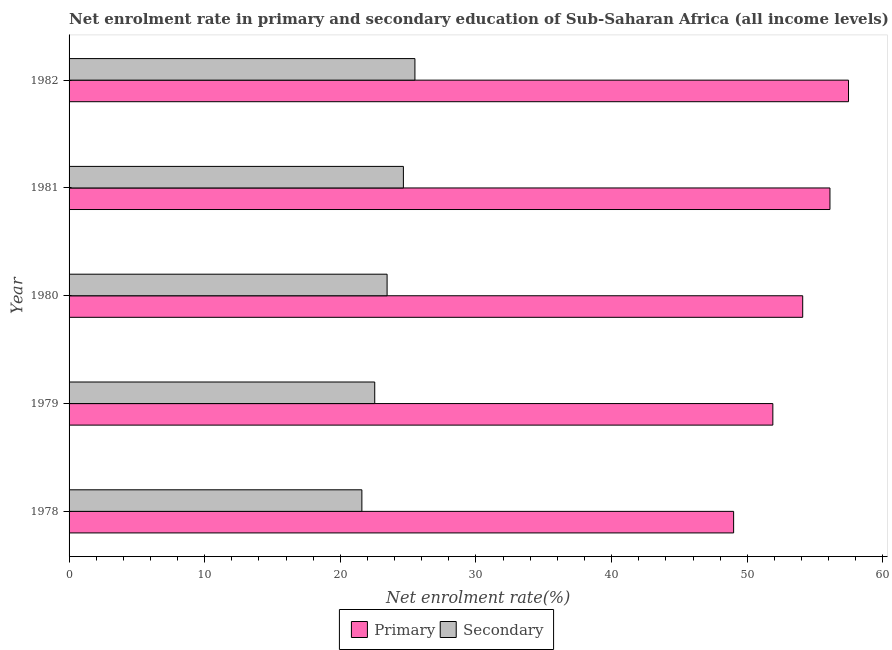How many groups of bars are there?
Your answer should be very brief. 5. How many bars are there on the 5th tick from the bottom?
Provide a succinct answer. 2. What is the label of the 2nd group of bars from the top?
Your response must be concise. 1981. What is the enrollment rate in primary education in 1980?
Your response must be concise. 54.09. Across all years, what is the maximum enrollment rate in secondary education?
Your answer should be very brief. 25.5. Across all years, what is the minimum enrollment rate in secondary education?
Provide a succinct answer. 21.59. In which year was the enrollment rate in secondary education maximum?
Ensure brevity in your answer.  1982. In which year was the enrollment rate in secondary education minimum?
Give a very brief answer. 1978. What is the total enrollment rate in primary education in the graph?
Offer a very short reply. 268.53. What is the difference between the enrollment rate in primary education in 1978 and that in 1981?
Your answer should be compact. -7.1. What is the difference between the enrollment rate in primary education in 1982 and the enrollment rate in secondary education in 1980?
Provide a succinct answer. 34.02. What is the average enrollment rate in primary education per year?
Offer a very short reply. 53.71. In the year 1982, what is the difference between the enrollment rate in secondary education and enrollment rate in primary education?
Your answer should be compact. -31.97. In how many years, is the enrollment rate in secondary education greater than 18 %?
Ensure brevity in your answer.  5. What is the ratio of the enrollment rate in primary education in 1980 to that in 1982?
Keep it short and to the point. 0.94. Is the difference between the enrollment rate in secondary education in 1980 and 1981 greater than the difference between the enrollment rate in primary education in 1980 and 1981?
Keep it short and to the point. Yes. What is the difference between the highest and the second highest enrollment rate in primary education?
Offer a very short reply. 1.37. What is the difference between the highest and the lowest enrollment rate in primary education?
Provide a short and direct response. 8.47. In how many years, is the enrollment rate in secondary education greater than the average enrollment rate in secondary education taken over all years?
Provide a succinct answer. 2. Is the sum of the enrollment rate in secondary education in 1978 and 1980 greater than the maximum enrollment rate in primary education across all years?
Ensure brevity in your answer.  No. What does the 2nd bar from the top in 1982 represents?
Ensure brevity in your answer.  Primary. What does the 1st bar from the bottom in 1980 represents?
Your answer should be compact. Primary. Does the graph contain any zero values?
Your answer should be very brief. No. Does the graph contain grids?
Provide a short and direct response. No. How are the legend labels stacked?
Provide a short and direct response. Horizontal. What is the title of the graph?
Your answer should be very brief. Net enrolment rate in primary and secondary education of Sub-Saharan Africa (all income levels). Does "Old" appear as one of the legend labels in the graph?
Keep it short and to the point. No. What is the label or title of the X-axis?
Your response must be concise. Net enrolment rate(%). What is the label or title of the Y-axis?
Provide a succinct answer. Year. What is the Net enrolment rate(%) of Primary in 1978?
Provide a succinct answer. 48.99. What is the Net enrolment rate(%) in Secondary in 1978?
Your response must be concise. 21.59. What is the Net enrolment rate(%) in Primary in 1979?
Provide a succinct answer. 51.89. What is the Net enrolment rate(%) of Secondary in 1979?
Make the answer very short. 22.54. What is the Net enrolment rate(%) in Primary in 1980?
Your response must be concise. 54.09. What is the Net enrolment rate(%) of Secondary in 1980?
Give a very brief answer. 23.45. What is the Net enrolment rate(%) in Primary in 1981?
Your answer should be compact. 56.1. What is the Net enrolment rate(%) of Secondary in 1981?
Provide a succinct answer. 24.65. What is the Net enrolment rate(%) in Primary in 1982?
Keep it short and to the point. 57.47. What is the Net enrolment rate(%) in Secondary in 1982?
Offer a terse response. 25.5. Across all years, what is the maximum Net enrolment rate(%) in Primary?
Offer a very short reply. 57.47. Across all years, what is the maximum Net enrolment rate(%) of Secondary?
Give a very brief answer. 25.5. Across all years, what is the minimum Net enrolment rate(%) of Primary?
Provide a succinct answer. 48.99. Across all years, what is the minimum Net enrolment rate(%) of Secondary?
Provide a succinct answer. 21.59. What is the total Net enrolment rate(%) of Primary in the graph?
Ensure brevity in your answer.  268.53. What is the total Net enrolment rate(%) in Secondary in the graph?
Make the answer very short. 117.71. What is the difference between the Net enrolment rate(%) in Primary in 1978 and that in 1979?
Your answer should be compact. -2.89. What is the difference between the Net enrolment rate(%) in Secondary in 1978 and that in 1979?
Your answer should be very brief. -0.95. What is the difference between the Net enrolment rate(%) in Primary in 1978 and that in 1980?
Offer a terse response. -5.09. What is the difference between the Net enrolment rate(%) of Secondary in 1978 and that in 1980?
Provide a succinct answer. -1.86. What is the difference between the Net enrolment rate(%) of Primary in 1978 and that in 1981?
Ensure brevity in your answer.  -7.1. What is the difference between the Net enrolment rate(%) in Secondary in 1978 and that in 1981?
Offer a very short reply. -3.06. What is the difference between the Net enrolment rate(%) of Primary in 1978 and that in 1982?
Give a very brief answer. -8.47. What is the difference between the Net enrolment rate(%) in Secondary in 1978 and that in 1982?
Make the answer very short. -3.91. What is the difference between the Net enrolment rate(%) of Primary in 1979 and that in 1980?
Provide a short and direct response. -2.2. What is the difference between the Net enrolment rate(%) in Secondary in 1979 and that in 1980?
Give a very brief answer. -0.91. What is the difference between the Net enrolment rate(%) of Primary in 1979 and that in 1981?
Provide a succinct answer. -4.21. What is the difference between the Net enrolment rate(%) of Secondary in 1979 and that in 1981?
Provide a succinct answer. -2.11. What is the difference between the Net enrolment rate(%) in Primary in 1979 and that in 1982?
Your answer should be very brief. -5.58. What is the difference between the Net enrolment rate(%) in Secondary in 1979 and that in 1982?
Ensure brevity in your answer.  -2.96. What is the difference between the Net enrolment rate(%) in Primary in 1980 and that in 1981?
Offer a very short reply. -2.01. What is the difference between the Net enrolment rate(%) of Secondary in 1980 and that in 1981?
Your answer should be very brief. -1.2. What is the difference between the Net enrolment rate(%) in Primary in 1980 and that in 1982?
Ensure brevity in your answer.  -3.38. What is the difference between the Net enrolment rate(%) of Secondary in 1980 and that in 1982?
Offer a terse response. -2.05. What is the difference between the Net enrolment rate(%) in Primary in 1981 and that in 1982?
Your answer should be very brief. -1.37. What is the difference between the Net enrolment rate(%) in Secondary in 1981 and that in 1982?
Your answer should be compact. -0.85. What is the difference between the Net enrolment rate(%) of Primary in 1978 and the Net enrolment rate(%) of Secondary in 1979?
Your response must be concise. 26.46. What is the difference between the Net enrolment rate(%) in Primary in 1978 and the Net enrolment rate(%) in Secondary in 1980?
Make the answer very short. 25.55. What is the difference between the Net enrolment rate(%) in Primary in 1978 and the Net enrolment rate(%) in Secondary in 1981?
Your response must be concise. 24.35. What is the difference between the Net enrolment rate(%) in Primary in 1978 and the Net enrolment rate(%) in Secondary in 1982?
Your answer should be very brief. 23.5. What is the difference between the Net enrolment rate(%) of Primary in 1979 and the Net enrolment rate(%) of Secondary in 1980?
Provide a short and direct response. 28.44. What is the difference between the Net enrolment rate(%) in Primary in 1979 and the Net enrolment rate(%) in Secondary in 1981?
Provide a short and direct response. 27.24. What is the difference between the Net enrolment rate(%) in Primary in 1979 and the Net enrolment rate(%) in Secondary in 1982?
Make the answer very short. 26.39. What is the difference between the Net enrolment rate(%) of Primary in 1980 and the Net enrolment rate(%) of Secondary in 1981?
Your response must be concise. 29.44. What is the difference between the Net enrolment rate(%) in Primary in 1980 and the Net enrolment rate(%) in Secondary in 1982?
Provide a short and direct response. 28.59. What is the difference between the Net enrolment rate(%) of Primary in 1981 and the Net enrolment rate(%) of Secondary in 1982?
Give a very brief answer. 30.6. What is the average Net enrolment rate(%) of Primary per year?
Keep it short and to the point. 53.71. What is the average Net enrolment rate(%) of Secondary per year?
Give a very brief answer. 23.54. In the year 1978, what is the difference between the Net enrolment rate(%) of Primary and Net enrolment rate(%) of Secondary?
Your answer should be very brief. 27.41. In the year 1979, what is the difference between the Net enrolment rate(%) of Primary and Net enrolment rate(%) of Secondary?
Give a very brief answer. 29.35. In the year 1980, what is the difference between the Net enrolment rate(%) in Primary and Net enrolment rate(%) in Secondary?
Your answer should be compact. 30.64. In the year 1981, what is the difference between the Net enrolment rate(%) in Primary and Net enrolment rate(%) in Secondary?
Give a very brief answer. 31.45. In the year 1982, what is the difference between the Net enrolment rate(%) in Primary and Net enrolment rate(%) in Secondary?
Offer a terse response. 31.97. What is the ratio of the Net enrolment rate(%) in Primary in 1978 to that in 1979?
Your answer should be compact. 0.94. What is the ratio of the Net enrolment rate(%) in Secondary in 1978 to that in 1979?
Provide a succinct answer. 0.96. What is the ratio of the Net enrolment rate(%) of Primary in 1978 to that in 1980?
Give a very brief answer. 0.91. What is the ratio of the Net enrolment rate(%) in Secondary in 1978 to that in 1980?
Provide a succinct answer. 0.92. What is the ratio of the Net enrolment rate(%) in Primary in 1978 to that in 1981?
Your answer should be compact. 0.87. What is the ratio of the Net enrolment rate(%) in Secondary in 1978 to that in 1981?
Your response must be concise. 0.88. What is the ratio of the Net enrolment rate(%) in Primary in 1978 to that in 1982?
Make the answer very short. 0.85. What is the ratio of the Net enrolment rate(%) in Secondary in 1978 to that in 1982?
Offer a terse response. 0.85. What is the ratio of the Net enrolment rate(%) in Primary in 1979 to that in 1980?
Offer a very short reply. 0.96. What is the ratio of the Net enrolment rate(%) of Secondary in 1979 to that in 1980?
Your response must be concise. 0.96. What is the ratio of the Net enrolment rate(%) of Primary in 1979 to that in 1981?
Offer a terse response. 0.92. What is the ratio of the Net enrolment rate(%) in Secondary in 1979 to that in 1981?
Provide a succinct answer. 0.91. What is the ratio of the Net enrolment rate(%) in Primary in 1979 to that in 1982?
Keep it short and to the point. 0.9. What is the ratio of the Net enrolment rate(%) of Secondary in 1979 to that in 1982?
Ensure brevity in your answer.  0.88. What is the ratio of the Net enrolment rate(%) in Primary in 1980 to that in 1981?
Offer a terse response. 0.96. What is the ratio of the Net enrolment rate(%) in Secondary in 1980 to that in 1981?
Your response must be concise. 0.95. What is the ratio of the Net enrolment rate(%) of Secondary in 1980 to that in 1982?
Your response must be concise. 0.92. What is the ratio of the Net enrolment rate(%) of Primary in 1981 to that in 1982?
Provide a short and direct response. 0.98. What is the ratio of the Net enrolment rate(%) of Secondary in 1981 to that in 1982?
Provide a short and direct response. 0.97. What is the difference between the highest and the second highest Net enrolment rate(%) in Primary?
Offer a terse response. 1.37. What is the difference between the highest and the second highest Net enrolment rate(%) of Secondary?
Keep it short and to the point. 0.85. What is the difference between the highest and the lowest Net enrolment rate(%) in Primary?
Give a very brief answer. 8.47. What is the difference between the highest and the lowest Net enrolment rate(%) of Secondary?
Offer a very short reply. 3.91. 